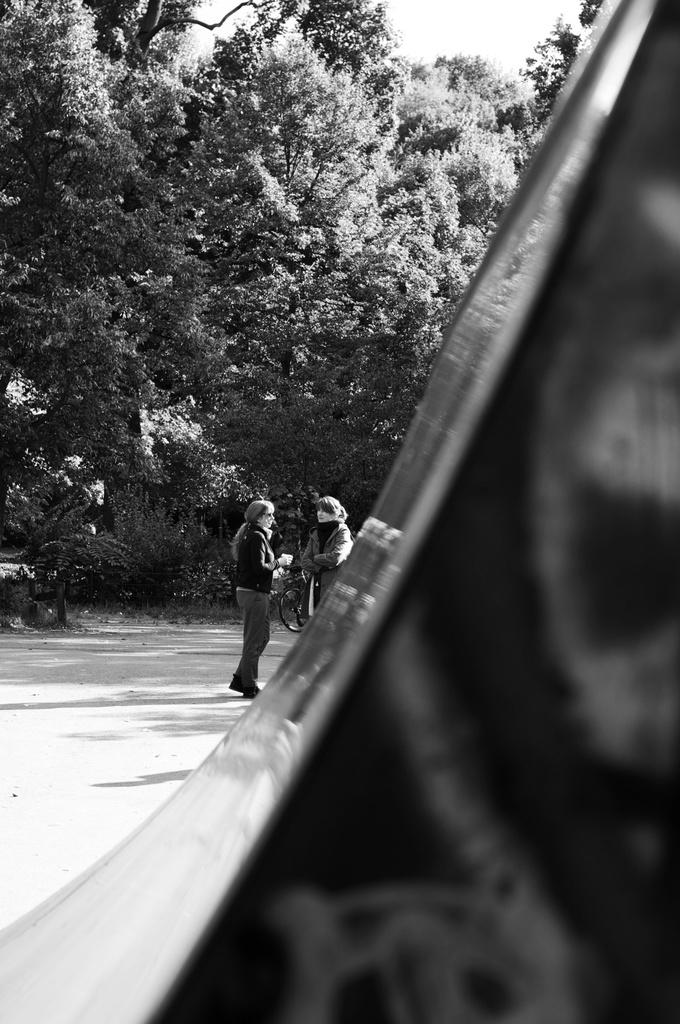How many people are present in the image? There are two persons standing in the image. What is the surface they are standing on? The persons are standing on land. What can be seen in the background of the image? There are trees and the sky visible in the background of the image. What is the color scheme of the image? The image is black and white. What is the name of the kitty that is sitting on the person's shoulder in the image? There is no kitty present in the image; it only features two persons standing on land. Can you tell me how many times the person in the image has copied their homework? There is no information about homework or copying in the image, as it only shows two persons standing on land. 